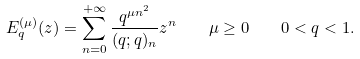<formula> <loc_0><loc_0><loc_500><loc_500>E _ { q } ^ { ( \mu ) } ( z ) = \sum _ { n = 0 } ^ { + \infty } \frac { q ^ { \mu n ^ { 2 } } } { ( q ; q ) _ { n } } z ^ { n } \quad \mu \geq 0 \quad 0 < q < 1 .</formula> 